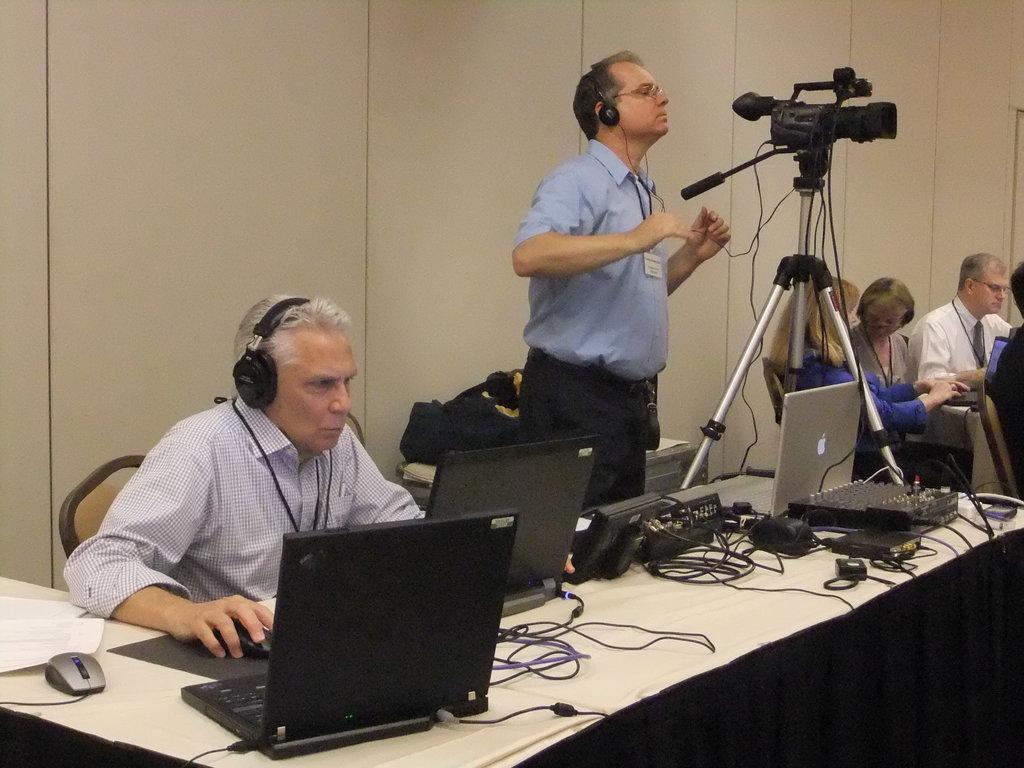How would you summarize this image in a sentence or two? In the picture I can see a man sitting on the chair and he is on the left side. He is wearing a shirt and he is working on a laptop. There is a man standing in the middle of the image and he is having a look at the camera screen. I can see four persons sitting on the chairs on the right side. There is a table on the floor and I can see the laptops, mouses and cables are kept on the table. 